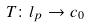Convert formula to latex. <formula><loc_0><loc_0><loc_500><loc_500>T \colon l _ { p } \rightarrow c _ { 0 }</formula> 